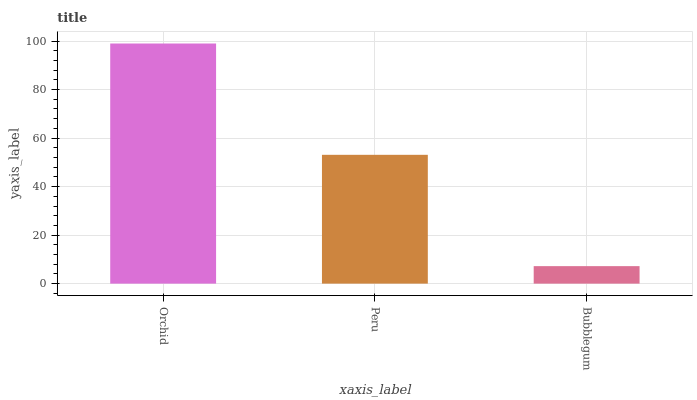Is Bubblegum the minimum?
Answer yes or no. Yes. Is Orchid the maximum?
Answer yes or no. Yes. Is Peru the minimum?
Answer yes or no. No. Is Peru the maximum?
Answer yes or no. No. Is Orchid greater than Peru?
Answer yes or no. Yes. Is Peru less than Orchid?
Answer yes or no. Yes. Is Peru greater than Orchid?
Answer yes or no. No. Is Orchid less than Peru?
Answer yes or no. No. Is Peru the high median?
Answer yes or no. Yes. Is Peru the low median?
Answer yes or no. Yes. Is Orchid the high median?
Answer yes or no. No. Is Orchid the low median?
Answer yes or no. No. 